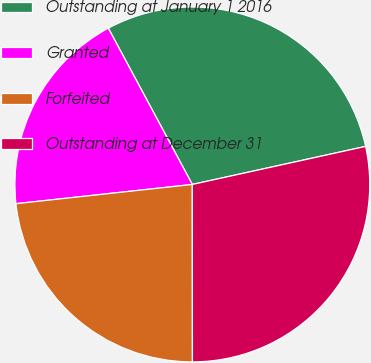Convert chart to OTSL. <chart><loc_0><loc_0><loc_500><loc_500><pie_chart><fcel>Outstanding at January 1 2016<fcel>Granted<fcel>Forfeited<fcel>Outstanding at December 31<nl><fcel>29.41%<fcel>18.88%<fcel>23.28%<fcel>28.43%<nl></chart> 